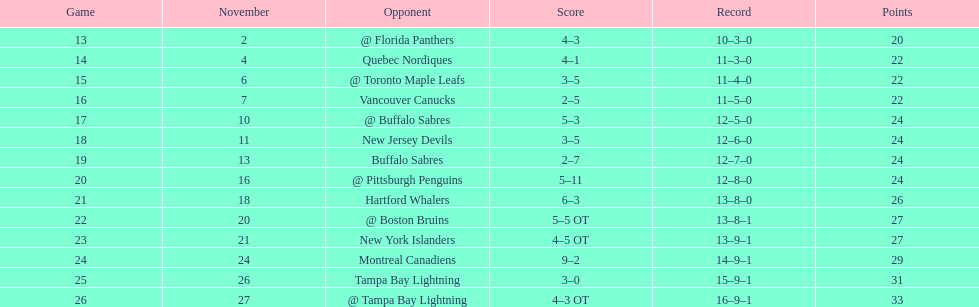Did the new jersey devils rank last based on the chart? No. 